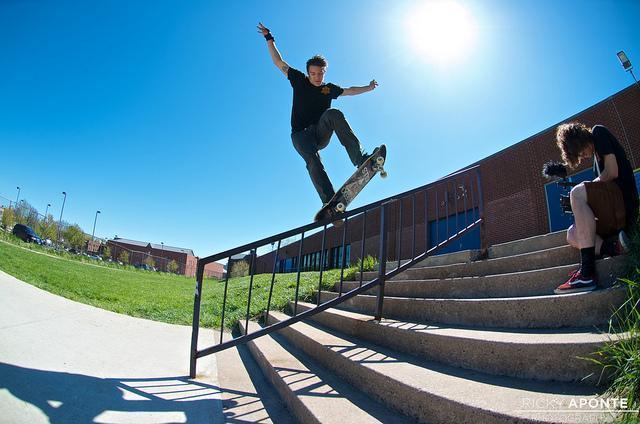Why is there a bright circle?
Pick the right solution, then justify: 'Answer: answer
Rationale: rationale.'
Options: Sun light, edited in, bright lamp, laser light. Answer: sun light.
Rationale: The sun is shinning so bright in the sky. 